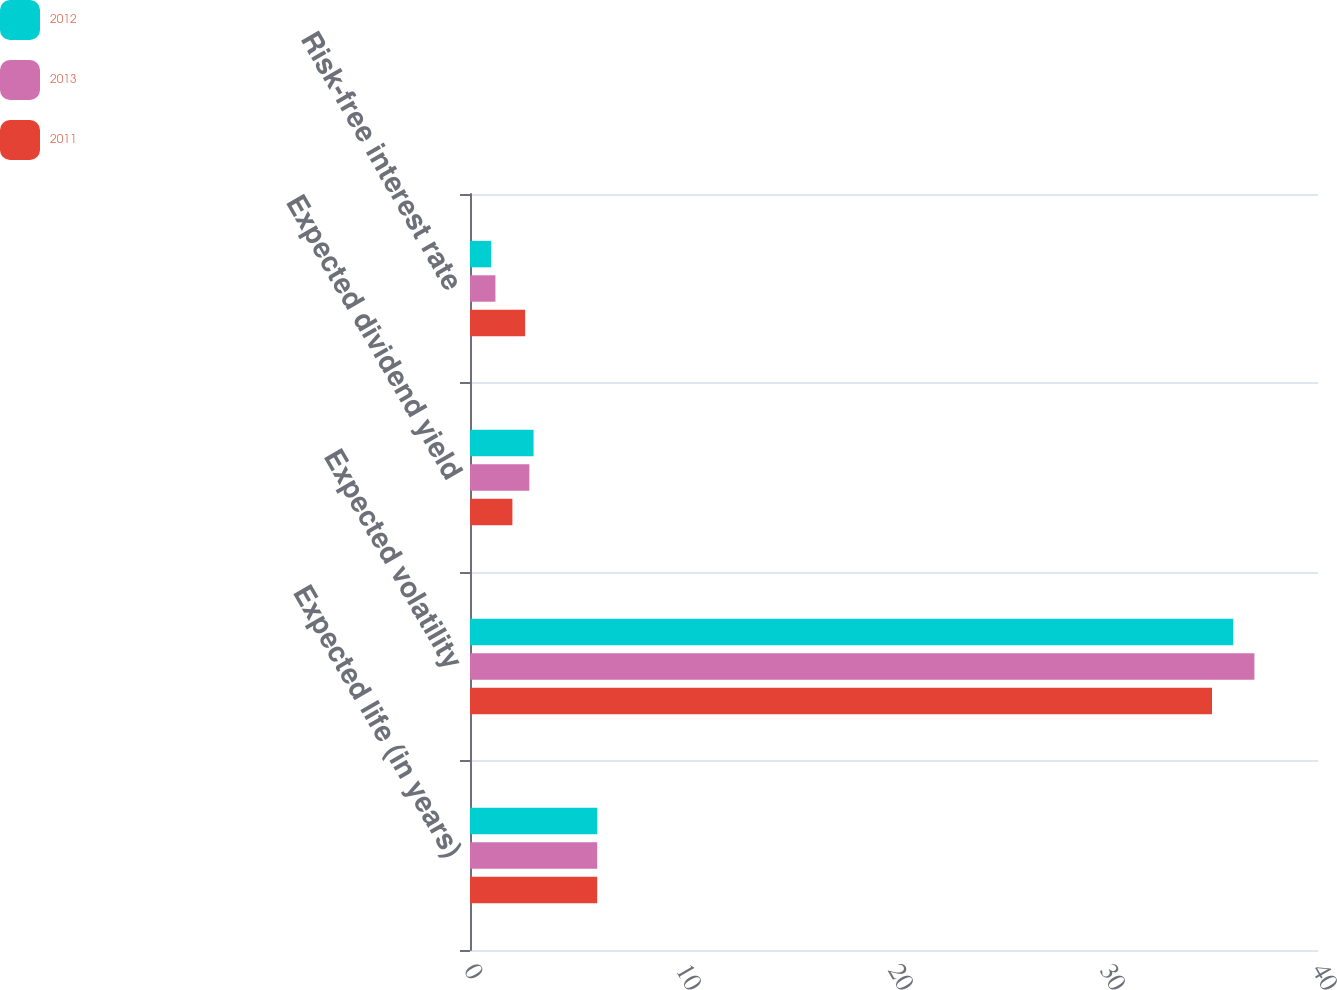<chart> <loc_0><loc_0><loc_500><loc_500><stacked_bar_chart><ecel><fcel>Expected life (in years)<fcel>Expected volatility<fcel>Expected dividend yield<fcel>Risk-free interest rate<nl><fcel>2012<fcel>6<fcel>36<fcel>3<fcel>1<nl><fcel>2013<fcel>6<fcel>37<fcel>2.8<fcel>1.2<nl><fcel>2011<fcel>6<fcel>35<fcel>2<fcel>2.6<nl></chart> 